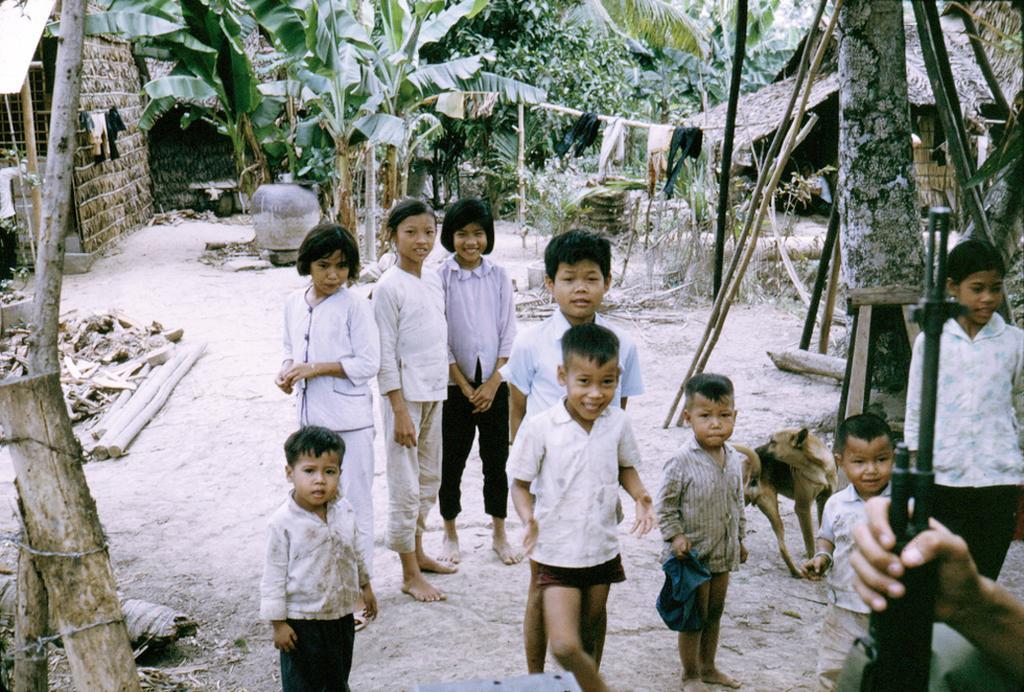Please provide a concise description of this image. There is a group of people and a dog present at the bottom of this image. There is one person holding a gun as we can see in the bottom right corner of this image. There are trees and other objects present in the background. 